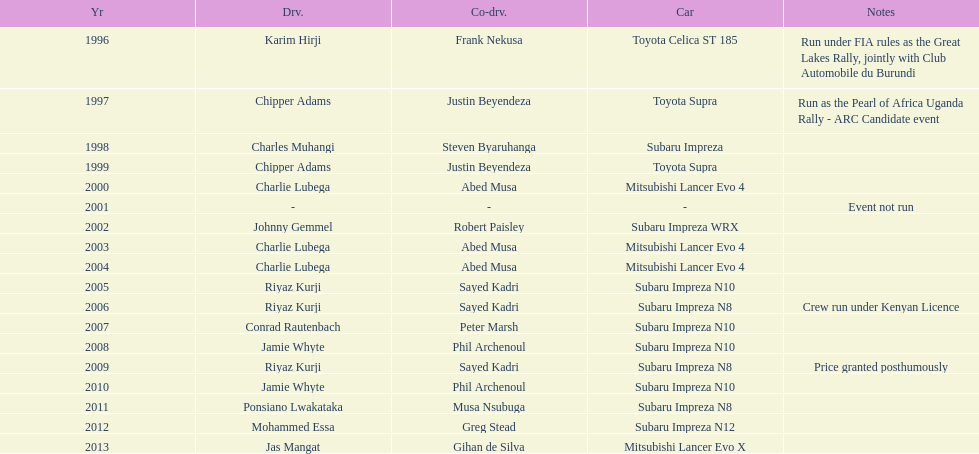Who is the sole driver with successive wins? Charlie Lubega. 